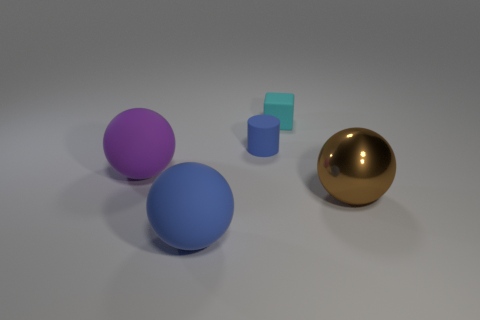What is the size of the block that is the same material as the big blue ball?
Make the answer very short. Small. How many cyan rubber things are the same shape as the large purple rubber object?
Ensure brevity in your answer.  0. How many objects are either big spheres to the right of the small matte cube or objects that are right of the large purple object?
Your answer should be compact. 4. There is a big sphere that is on the right side of the small matte cube; what number of objects are on the left side of it?
Offer a terse response. 4. Does the tiny rubber thing to the left of the cyan rubber cube have the same shape as the thing to the right of the cyan matte object?
Make the answer very short. No. There is a rubber thing that is the same color as the cylinder; what shape is it?
Your response must be concise. Sphere. Is there a big purple ball that has the same material as the small cube?
Provide a short and direct response. Yes. What number of metal things are either tiny blocks or gray spheres?
Provide a succinct answer. 0. What shape is the large object that is to the right of the rubber sphere that is in front of the brown ball?
Ensure brevity in your answer.  Sphere. Is the number of small blocks that are in front of the cyan block less than the number of small green shiny spheres?
Provide a short and direct response. No. 